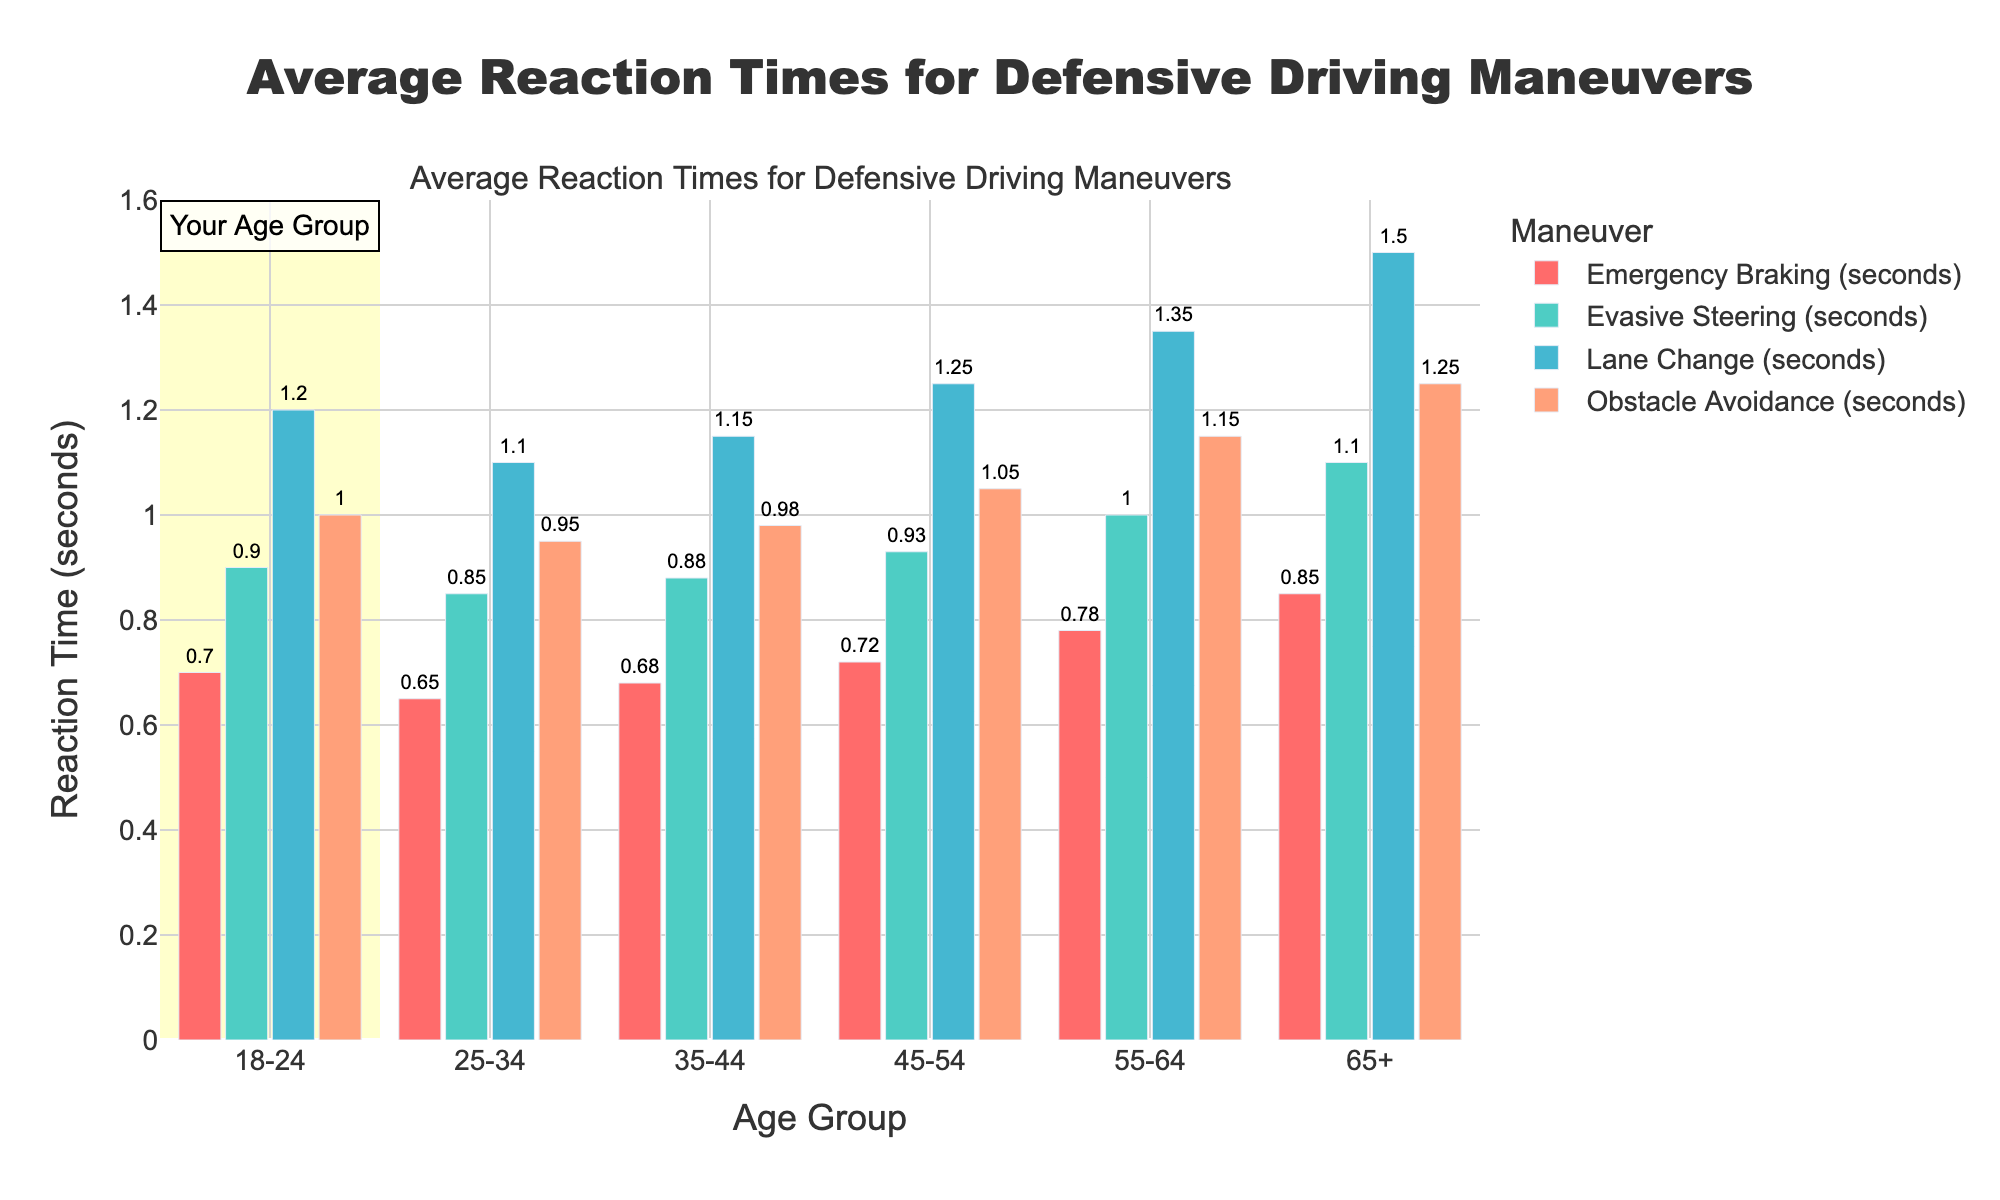What age group has the quickest reaction time for emergency braking? The bar for emergency braking is the shortest for the 25-34 age group.
Answer: 25-34 Which defensive driving maneuver consistently takes the longest time across all age groups? By visually comparing the heights of the bars, the Lane Change maneuver consistently has the highest bars across all age groups.
Answer: Lane Change What is the average reaction time for the evasive steering maneuver across all age groups? Add the reaction times for Evasive Steering across all age groups (0.9 + 0.85 + 0.88 + 0.93 + 1.0 + 1.1) and divide by 6. Average = (5.66 / 6) = 0.943 seconds.
Answer: 0.94 seconds How does the reaction time for obstacle avoidance for the 18-24 age group compare to the 65+ age group? The reaction time for the 18-24 age group is 1.0 seconds, and for the 65+ age group, it is 1.25 seconds. The older age group is slower by 0.25 seconds.
Answer: 0.25 seconds slower What is the total reaction time for all maneuvers combined for the 55-64 age group? Add reaction times for all maneuvers for the 55-64 age group (0.78 + 1.0 + 1.35 + 1.15). Total = 4.28 seconds.
Answer: 4.28 seconds Which maneuver has the smallest increase in reaction time from the 18-24 age group to the 65+ age group? Calculate the increase for each maneuver: Emergency Braking (0.85 - 0.7 = 0.15), Evasive Steering (1.1 - 0.9 = 0.2), Lane Change (1.5 - 1.2 = 0.3), Obstacle Avoidance (1.25 - 1.0 = 0.25). The smallest increase is for Emergency Braking by 0.15 seconds.
Answer: Emergency Braking What is the difference in reaction time for lane changes between the 18-24 and 45-54 age groups? The reaction time for Lane Change for the 18-24 age group is 1.2 seconds, and for the 45-54 age group, it is 1.25 seconds. The difference is 1.25 - 1.2 = 0.05 seconds.
Answer: 0.05 seconds Which age group shows the most significant variance in reaction times across all maneuvers? Calculate the range (maximum - minimum) for each age group: 
18-24 (1.2 - 0.7 = 0.5), 
25-34 (1.1 - 0.65 = 0.45), 
35-44 (1.15 - 0.68 = 0.47), 
45-54 (1.25 - 0.72 = 0.53), 
55-64 (1.35 - 0.78 = 0.57), 
65+ (1.5 - 0.85 = 0.65). 
The most significant variance is for the 65+ age group with 0.65 seconds.
Answer: 65+ How does the reaction time for emergency braking in the 18-24 age group compare to its reaction time for lane changes? The reaction time for emergency braking in the 18-24 age group is 0.7 seconds, and the lane change is 1.2 seconds. The difference is 1.2 - 0.7 = 0.5 seconds.
Answer: 0.5 seconds 